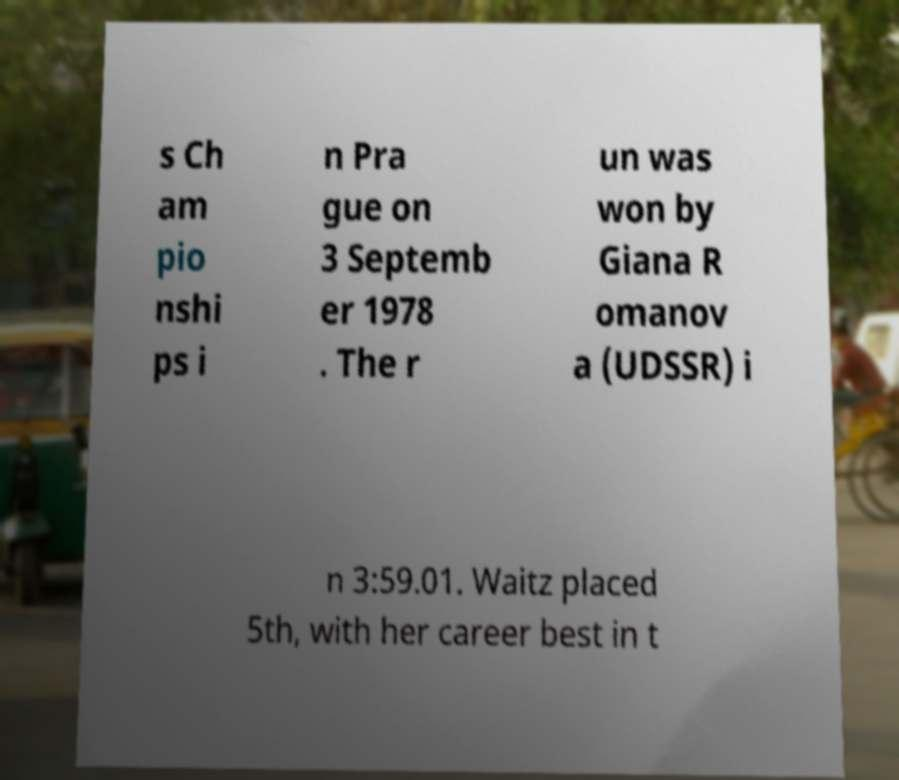There's text embedded in this image that I need extracted. Can you transcribe it verbatim? s Ch am pio nshi ps i n Pra gue on 3 Septemb er 1978 . The r un was won by Giana R omanov a (UDSSR) i n 3:59.01. Waitz placed 5th, with her career best in t 